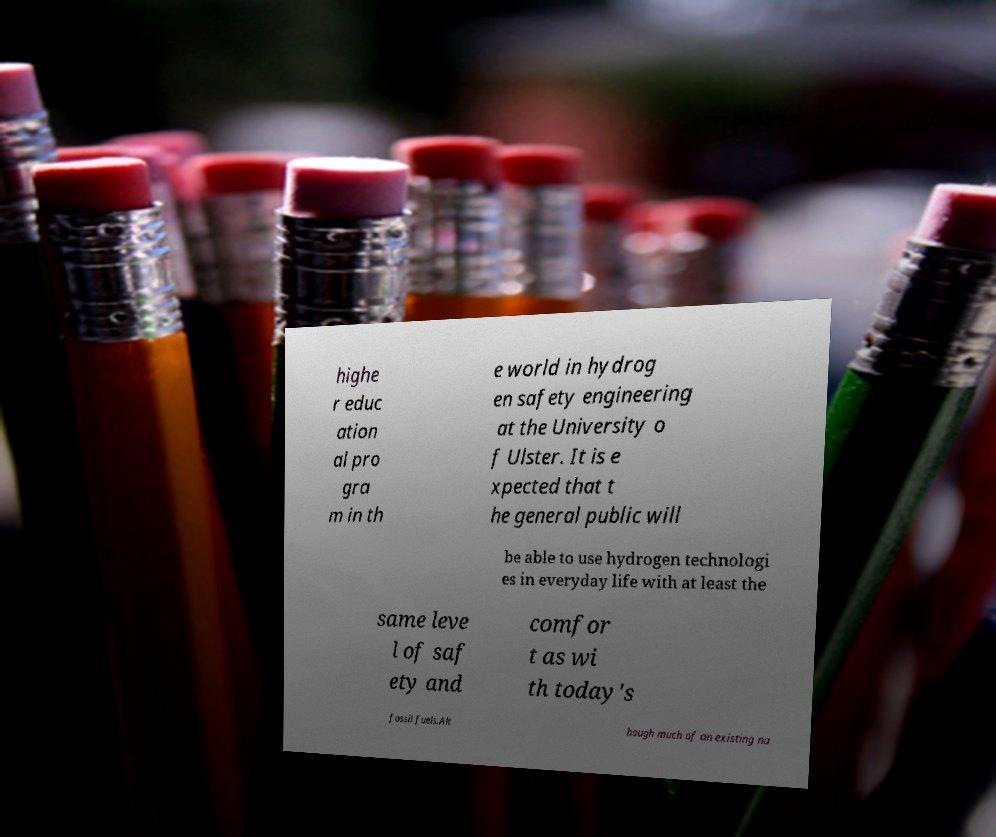Could you assist in decoding the text presented in this image and type it out clearly? highe r educ ation al pro gra m in th e world in hydrog en safety engineering at the University o f Ulster. It is e xpected that t he general public will be able to use hydrogen technologi es in everyday life with at least the same leve l of saf ety and comfor t as wi th today's fossil fuels.Alt hough much of an existing na 